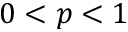Convert formula to latex. <formula><loc_0><loc_0><loc_500><loc_500>0 < p < 1</formula> 